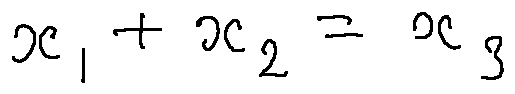Convert formula to latex. <formula><loc_0><loc_0><loc_500><loc_500>x _ { 1 } + x _ { 2 } = x _ { 3 }</formula> 